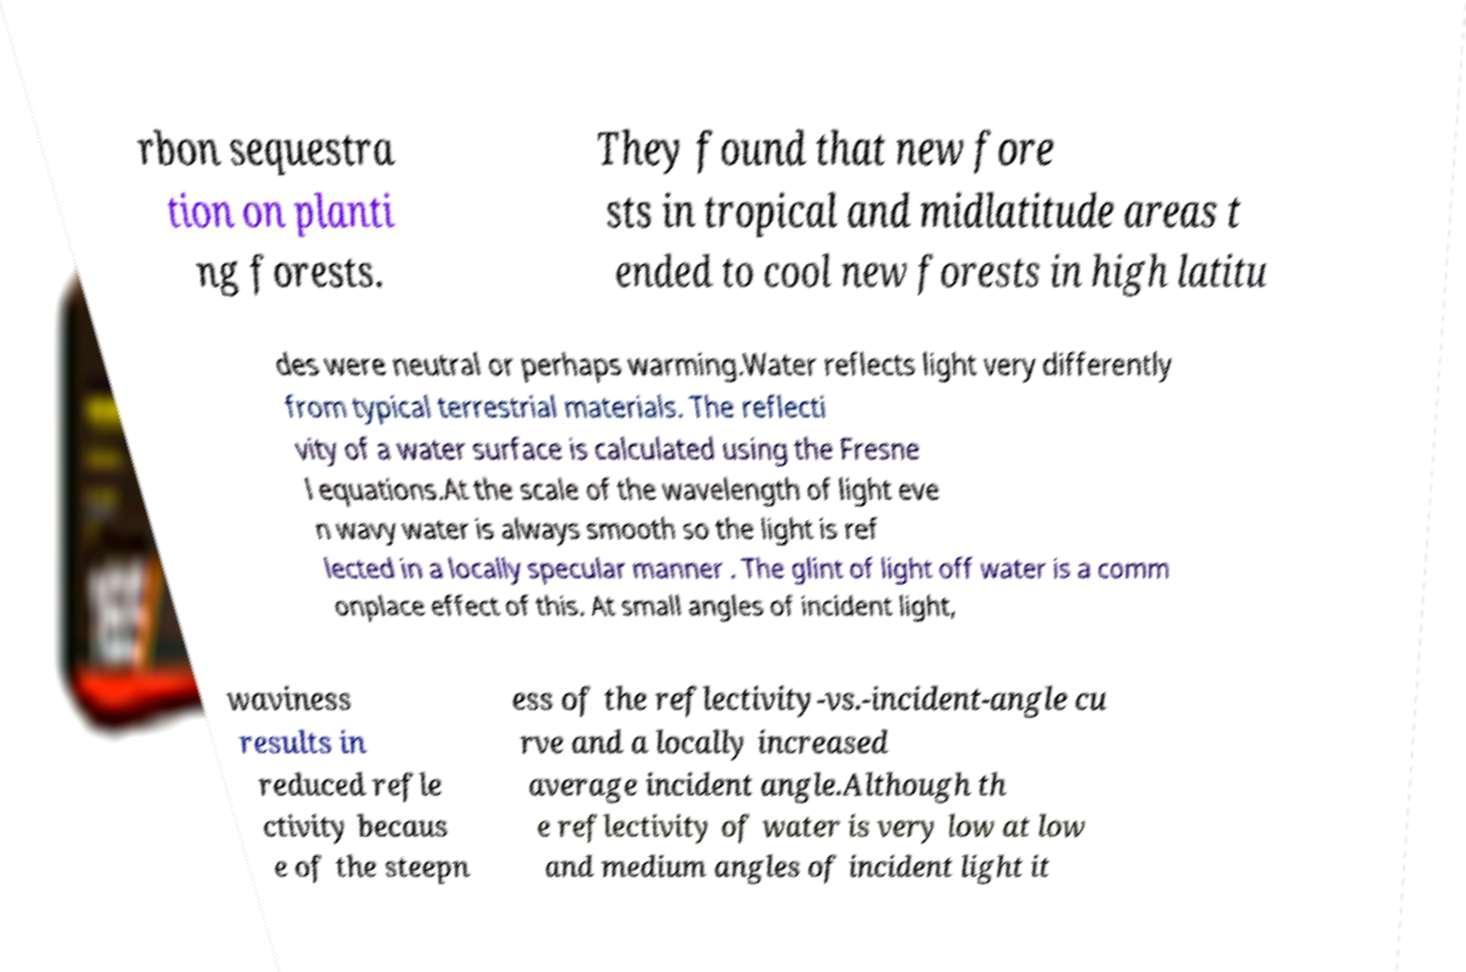There's text embedded in this image that I need extracted. Can you transcribe it verbatim? rbon sequestra tion on planti ng forests. They found that new fore sts in tropical and midlatitude areas t ended to cool new forests in high latitu des were neutral or perhaps warming.Water reflects light very differently from typical terrestrial materials. The reflecti vity of a water surface is calculated using the Fresne l equations.At the scale of the wavelength of light eve n wavy water is always smooth so the light is ref lected in a locally specular manner . The glint of light off water is a comm onplace effect of this. At small angles of incident light, waviness results in reduced refle ctivity becaus e of the steepn ess of the reflectivity-vs.-incident-angle cu rve and a locally increased average incident angle.Although th e reflectivity of water is very low at low and medium angles of incident light it 